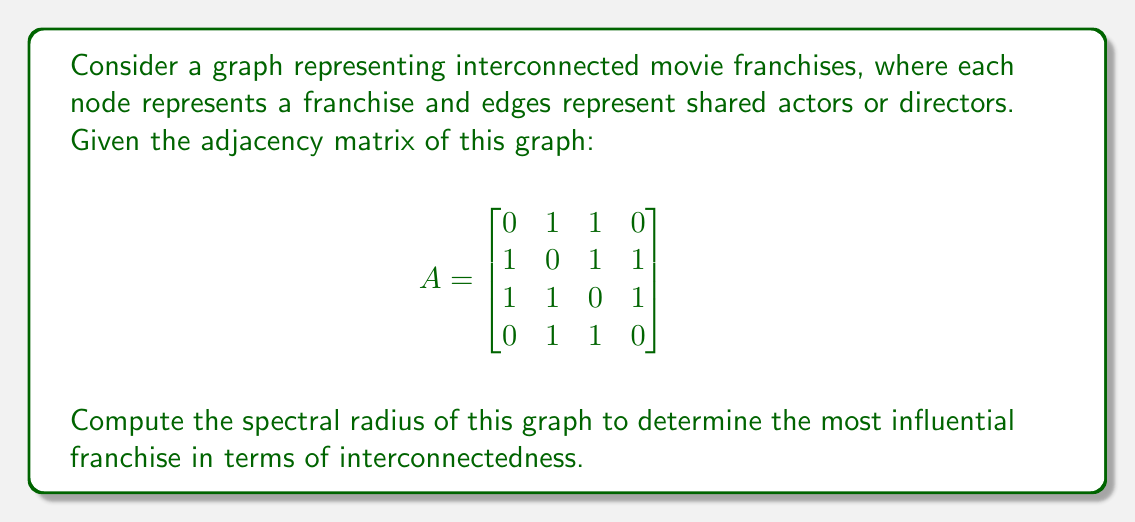Can you answer this question? To find the spectral radius of the graph, we need to follow these steps:

1. Calculate the eigenvalues of the adjacency matrix A.
2. Find the maximum absolute value among these eigenvalues.

Step 1: Calculate the eigenvalues

To find the eigenvalues, we need to solve the characteristic equation:
$$\det(A - \lambda I) = 0$$

Expanding this determinant:

$$\begin{vmatrix}
-\lambda & 1 & 1 & 0 \\
1 & -\lambda & 1 & 1 \\
1 & 1 & -\lambda & 1 \\
0 & 1 & 1 & -\lambda
\end{vmatrix} = 0$$

This gives us the characteristic polynomial:
$$\lambda^4 - 5\lambda^2 + 4 = 0$$

Solving this equation:
$$(\lambda^2 - 1)(\lambda^2 - 4) = 0$$

The eigenvalues are:
$$\lambda = \pm 1, \pm 2$$

Step 2: Find the maximum absolute value

The spectral radius is the largest absolute value among the eigenvalues. In this case, it's 2.

Therefore, the spectral radius of the graph is 2, indicating that the most influential franchise in terms of interconnectedness has an influence factor of 2.
Answer: 2 